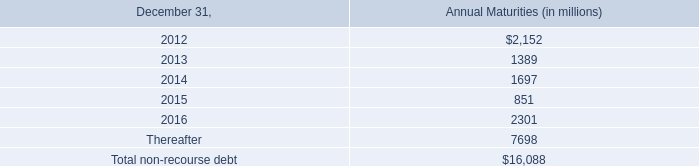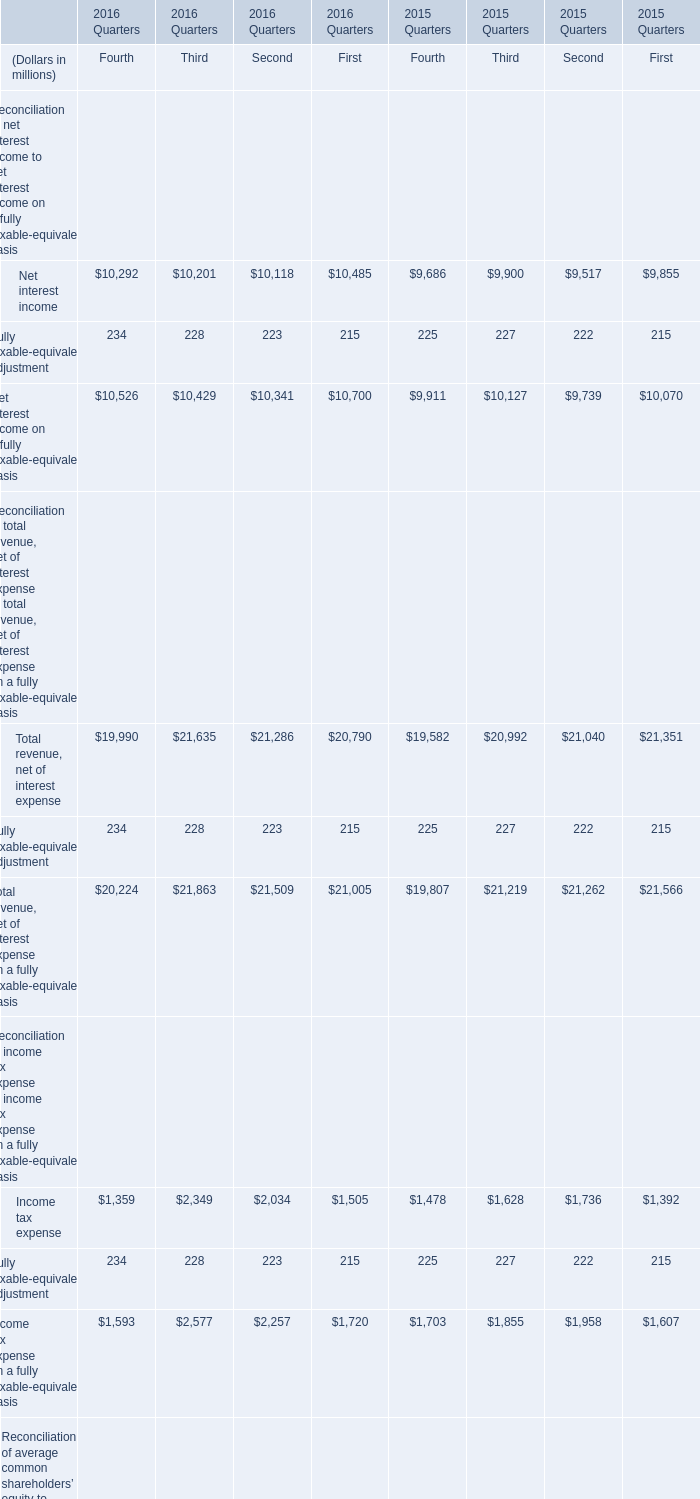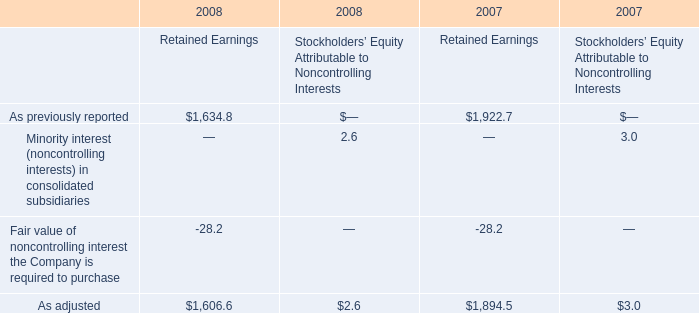as of december 31 , 2011 , what is the total in billions available under the committed credit facilities? 
Computations: (1.4 + 1.2)
Answer: 2.6. 